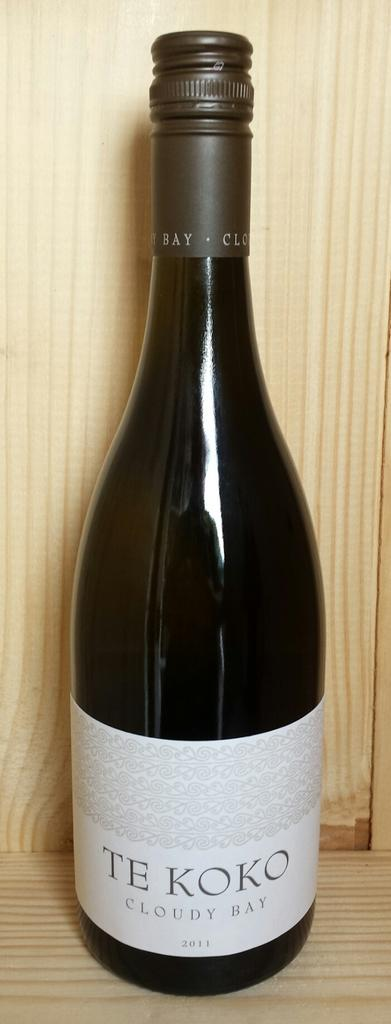<image>
Give a short and clear explanation of the subsequent image. A bottle "Te Koko" wine sitting on a shelf 